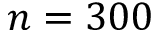Convert formula to latex. <formula><loc_0><loc_0><loc_500><loc_500>n = 3 0 0</formula> 